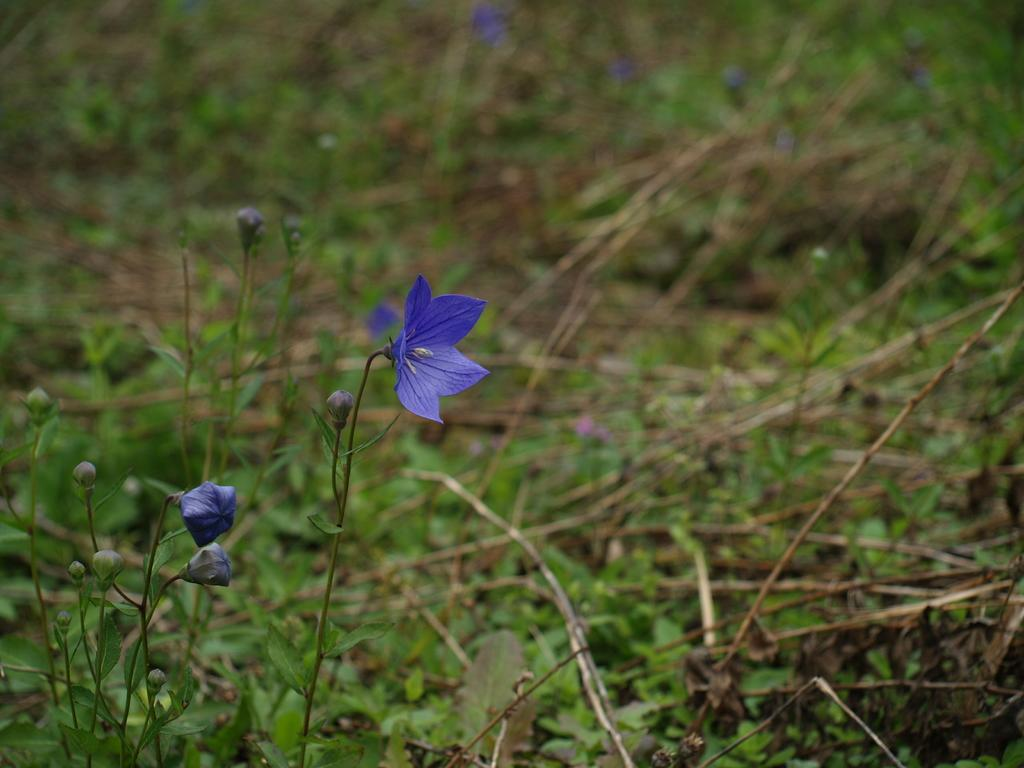What type of plant can be seen in the image? There is a flower in the image. What stage of growth are the plants in the image? There are buds on the plants in the image. What type of vegetation is visible in the background of the image? The background of the image includes grass. What else can be seen in the background of the image? There are plants in the background of the image. What type of veil is draped over the flower in the image? There is no veil present in the image; it is a flower with buds on the plants. 